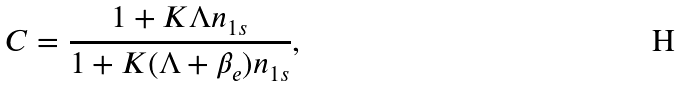<formula> <loc_0><loc_0><loc_500><loc_500>C = \frac { 1 + K \Lambda n _ { 1 s } } { 1 + K ( \Lambda + \beta _ { e } ) n _ { 1 s } } ,</formula> 